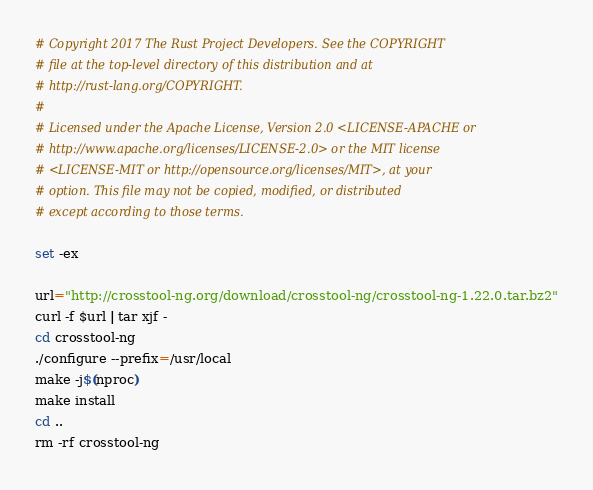Convert code to text. <code><loc_0><loc_0><loc_500><loc_500><_Bash_># Copyright 2017 The Rust Project Developers. See the COPYRIGHT
# file at the top-level directory of this distribution and at
# http://rust-lang.org/COPYRIGHT.
#
# Licensed under the Apache License, Version 2.0 <LICENSE-APACHE or
# http://www.apache.org/licenses/LICENSE-2.0> or the MIT license
# <LICENSE-MIT or http://opensource.org/licenses/MIT>, at your
# option. This file may not be copied, modified, or distributed
# except according to those terms.

set -ex

url="http://crosstool-ng.org/download/crosstool-ng/crosstool-ng-1.22.0.tar.bz2"
curl -f $url | tar xjf -
cd crosstool-ng
./configure --prefix=/usr/local
make -j$(nproc)
make install
cd ..
rm -rf crosstool-ng
</code> 